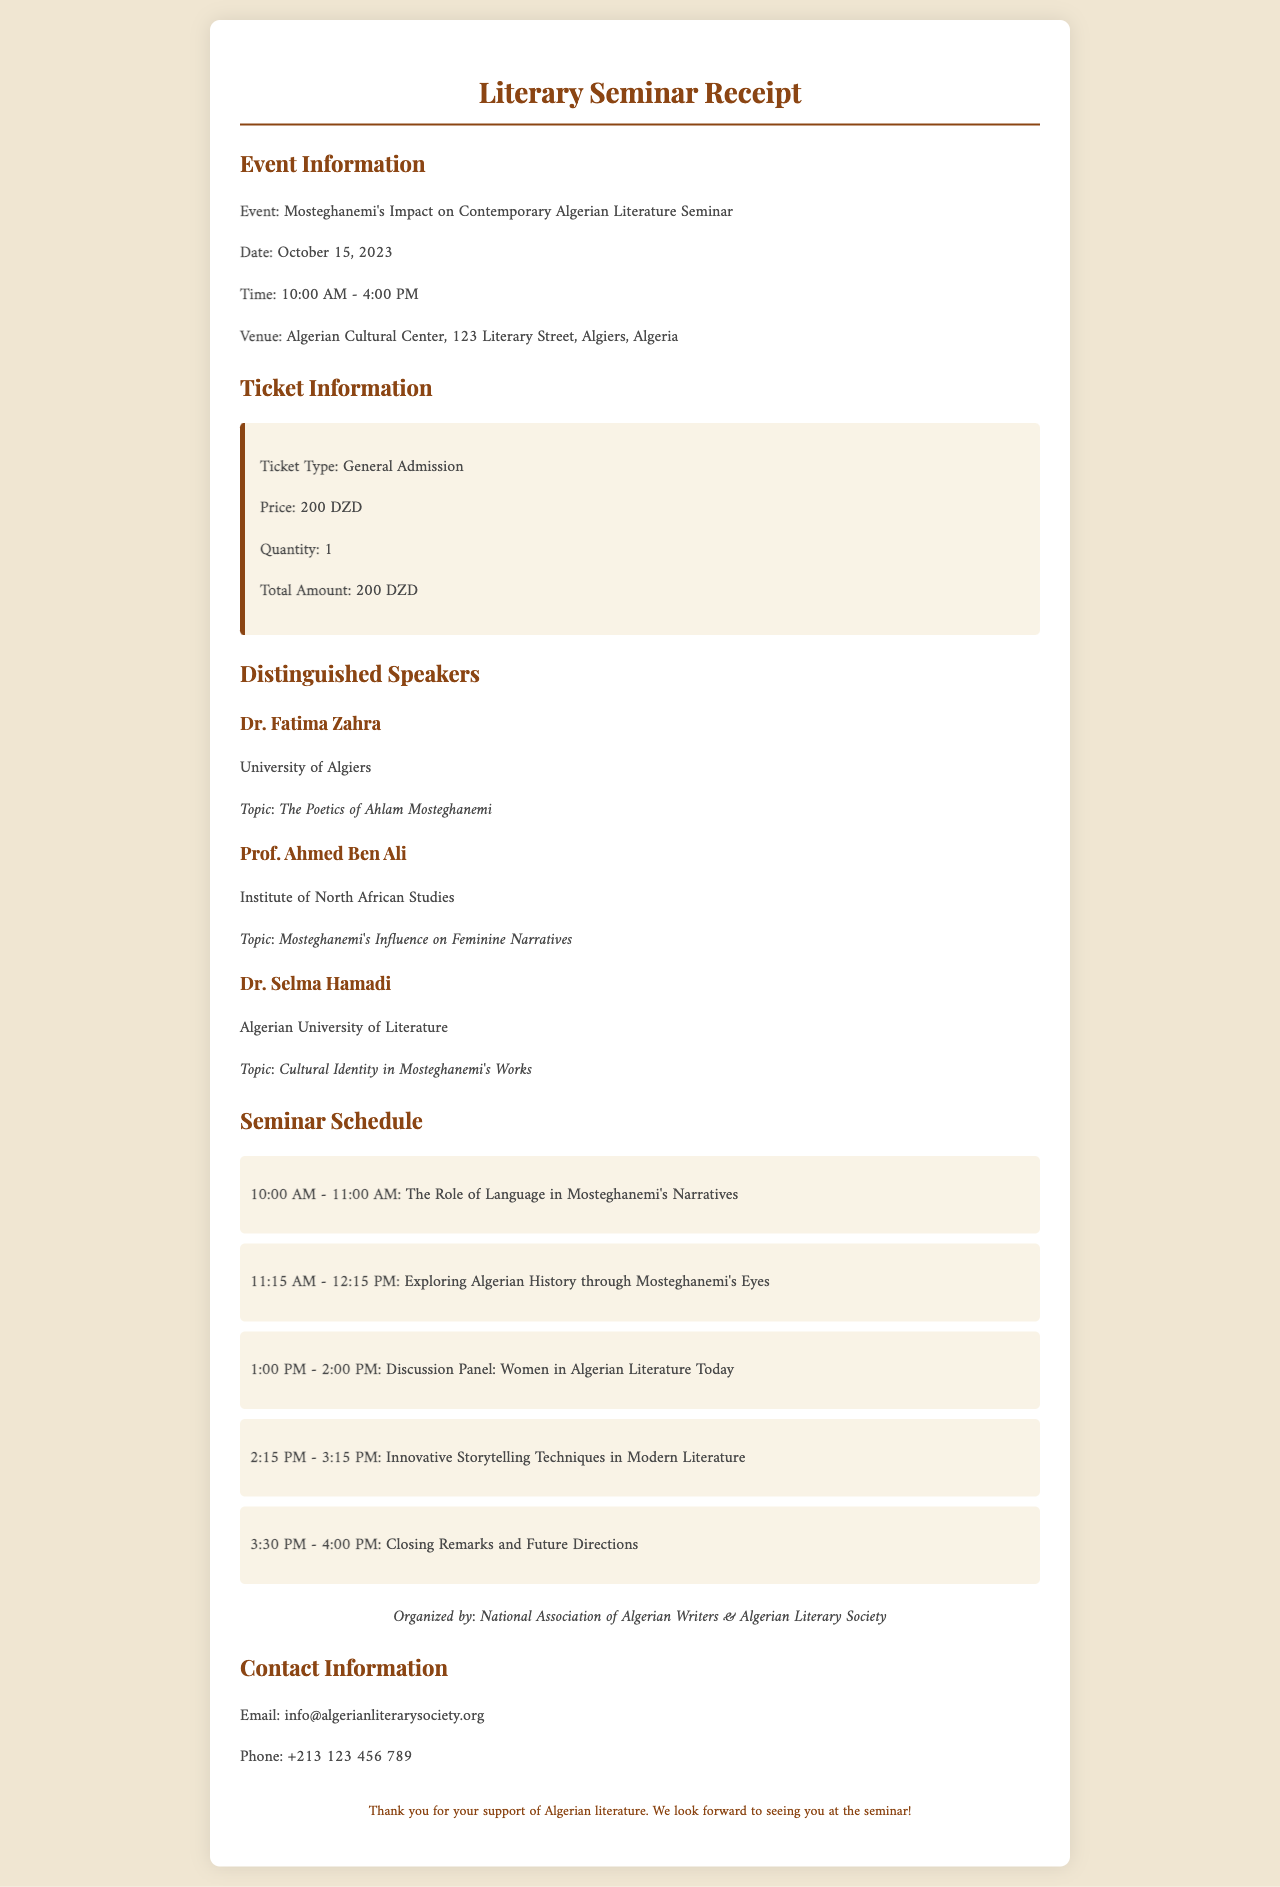What is the event name? The event name is explicitly stated in the document under Event Information.
Answer: Mosteghanemi's Impact on Contemporary Algerian Literature Seminar What is the price of the ticket? The ticket price is detailed in the Ticket Information section.
Answer: 200 DZD What is the date of the seminar? The date of the seminar is provided in the Event Information section.
Answer: October 15, 2023 Who is one of the distinguished speakers? The document lists multiple speakers in the Distinguished Speakers section.
Answer: Dr. Fatima Zahra What time does the seminar start? The starting time of the seminar is mentioned in the Event Information.
Answer: 10:00 AM What will be discussed during the 1 PM session? The schedule section provides details on what will be discussed at various times.
Answer: Discussion Panel: Women in Algerian Literature Today Who organized the seminar? The organizers' names are mentioned at the bottom of the document.
Answer: National Association of Algerian Writers & Algerian Literary Society What is the venue for the event? The venue is specifically mentioned in the Event Information section.
Answer: Algerian Cultural Center, 123 Literary Street, Algiers, Algeria What is the total amount due on the receipt? The total amount is specified in the Ticket Information section.
Answer: 200 DZD 